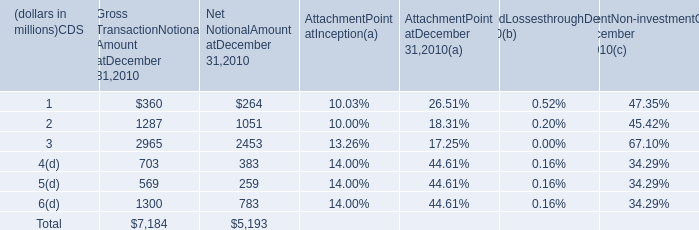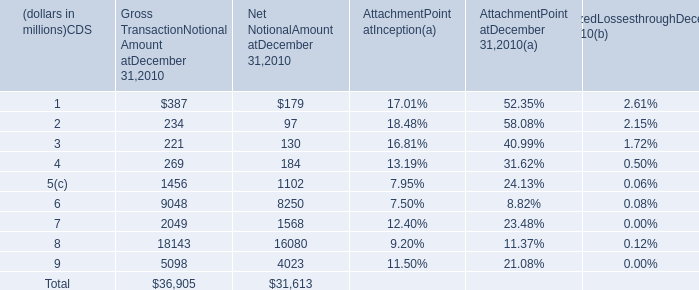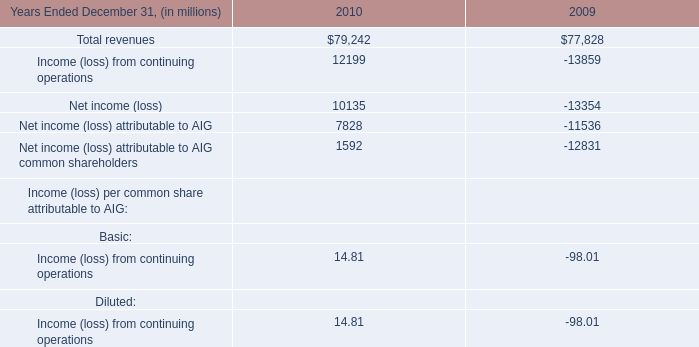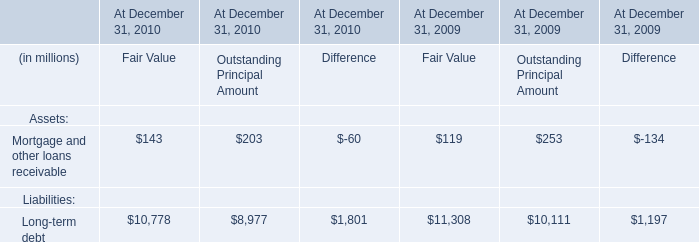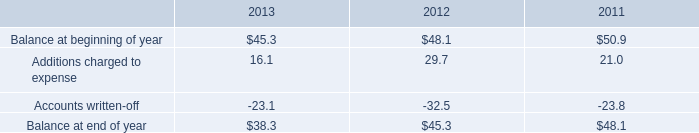What's the total amount of Net Notional Amount at December 31,2010 excluding those Net Notional Amount at December 31,2010 greater than 1000 in 2010? (in million) 
Computations: (((264 + 383) + 259) + 783)
Answer: 1689.0. 